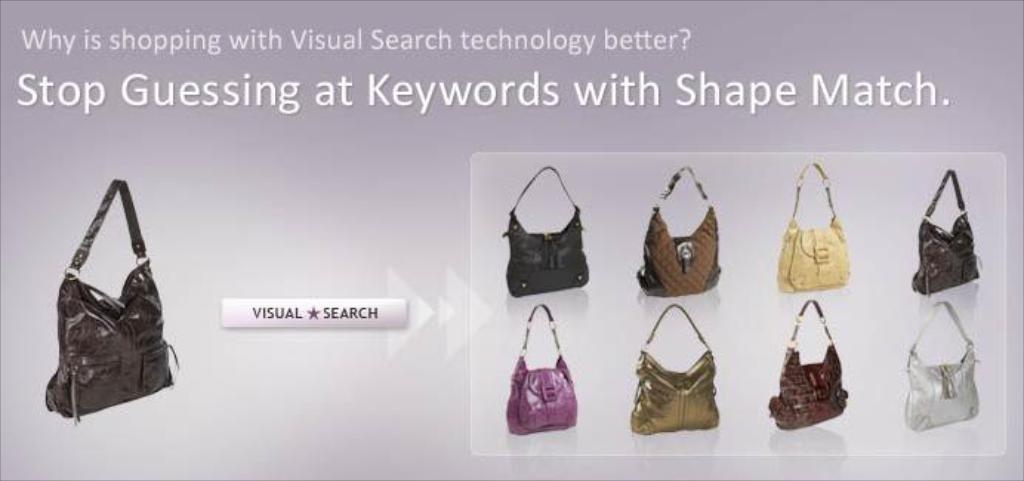Could you give a brief overview of what you see in this image? Here we can see a web page having handbags with various colors present in it 